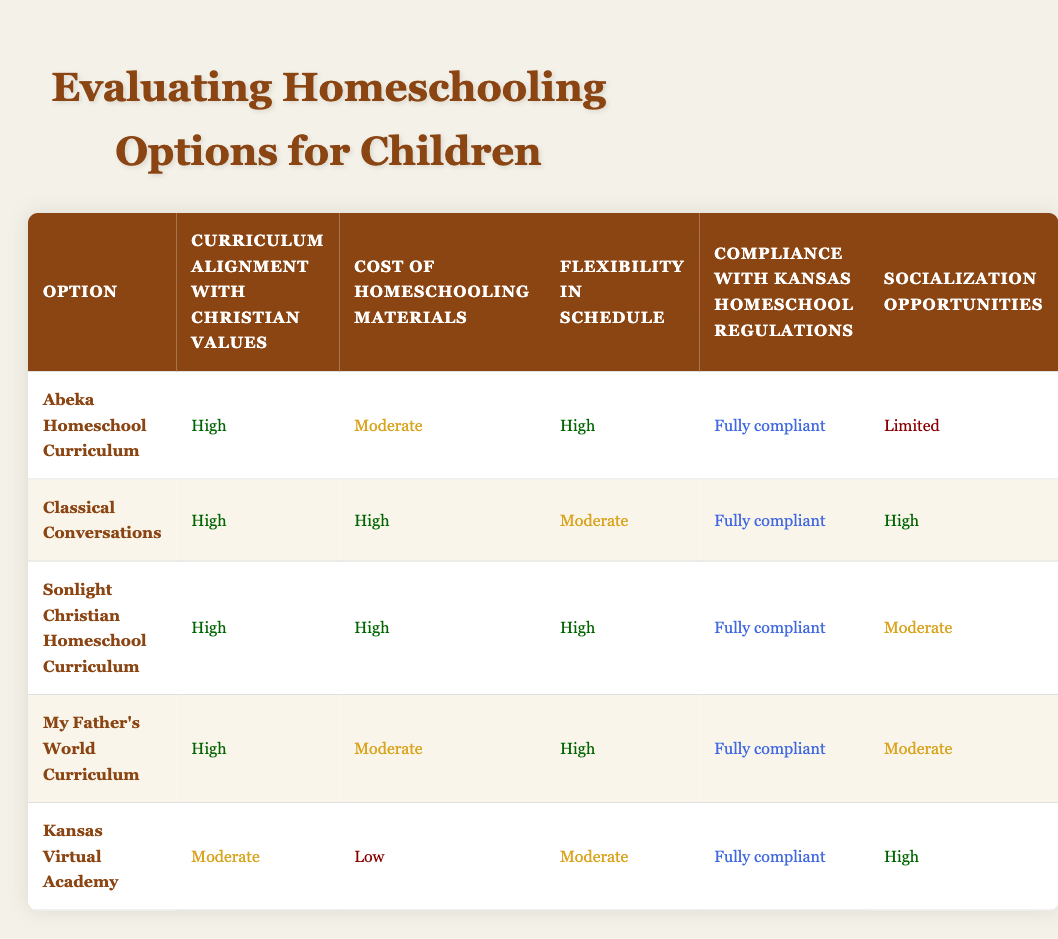What is the curriculum alignment with Christian values for "Sonlight Christian Homeschool Curriculum"? The table shows that "Sonlight Christian Homeschool Curriculum" has a curriculum alignment with Christian values rated as "High."
Answer: High Which homeschooling option has the lowest cost of homeschooling materials? Looking at the "Cost of homeschooling materials" column, "Kansas Virtual Academy" is listed as having a "Low" cost, which is the lowest among all options.
Answer: Kansas Virtual Academy For which option is flexibility in schedule rated the highest? The "Flexibility in schedule" column indicates that both "Abeka Homeschool Curriculum," "Sonlight Christian Homeschool Curriculum," and "My Father's World Curriculum" are rated "High," but "Sonlight Christian Homeschool Curriculum" also has a high rating for curriculum alignment, which makes it stand out.
Answer: Abeka Homeschool Curriculum, Sonlight Christian Homeschool Curriculum, My Father's World Curriculum Is "Classical Conversations" fully compliant with Kansas homeschool regulations? According to the table, "Classical Conversations" is listed as "Fully compliant" with Kansas homeschool regulations, which is a positive aspect for considering this option.
Answer: Yes What is the average evaluation of socialization opportunities across all five curriculum options? To find the average, we convert the socialization opportunity ratings into numerical values (High=3, Moderate=2, Limited=1, Low=0). The options evaluate as follows: "Abeka Homeschool Curriculum" (1), "Classical Conversations" (3), "Sonlight Christian Homeschool Curriculum" (2), "My Father's World Curriculum" (2), and "Kansas Virtual Academy" (3). The sum is 1 + 3 + 2 + 2 + 3 = 11. There are 5 options, so the average is 11/5 = 2.2, which averages around 2.
Answer: 2.2 Which curriculum option offers both high flexibility in schedule and high socialization opportunities? "Classical Conversations" is the only option that presents a "High" rating in both "Flexibility in schedule" and "Socialization opportunities." This makes it an attractive choice for families valuing these aspects.
Answer: Classical Conversations 